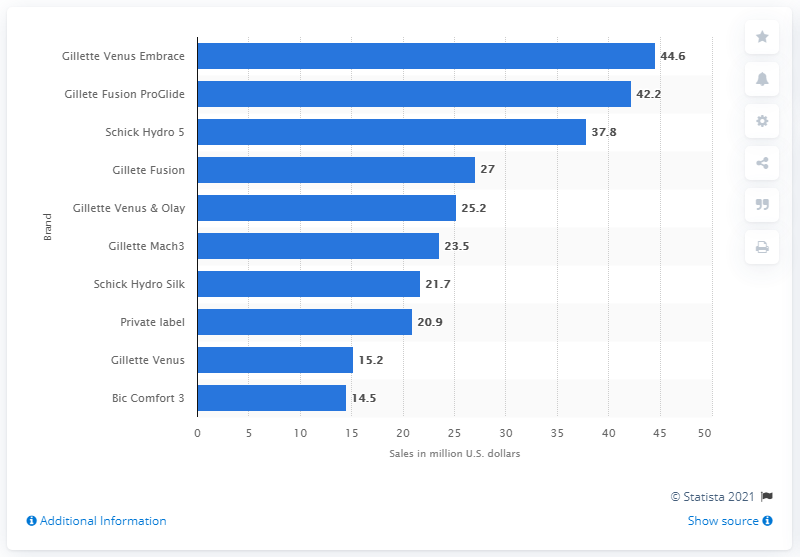Identify some key points in this picture. In June 2014, Gillette Venus Embrace generated $44.6 million in sales. 